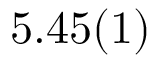Convert formula to latex. <formula><loc_0><loc_0><loc_500><loc_500>5 . 4 5 ( 1 )</formula> 